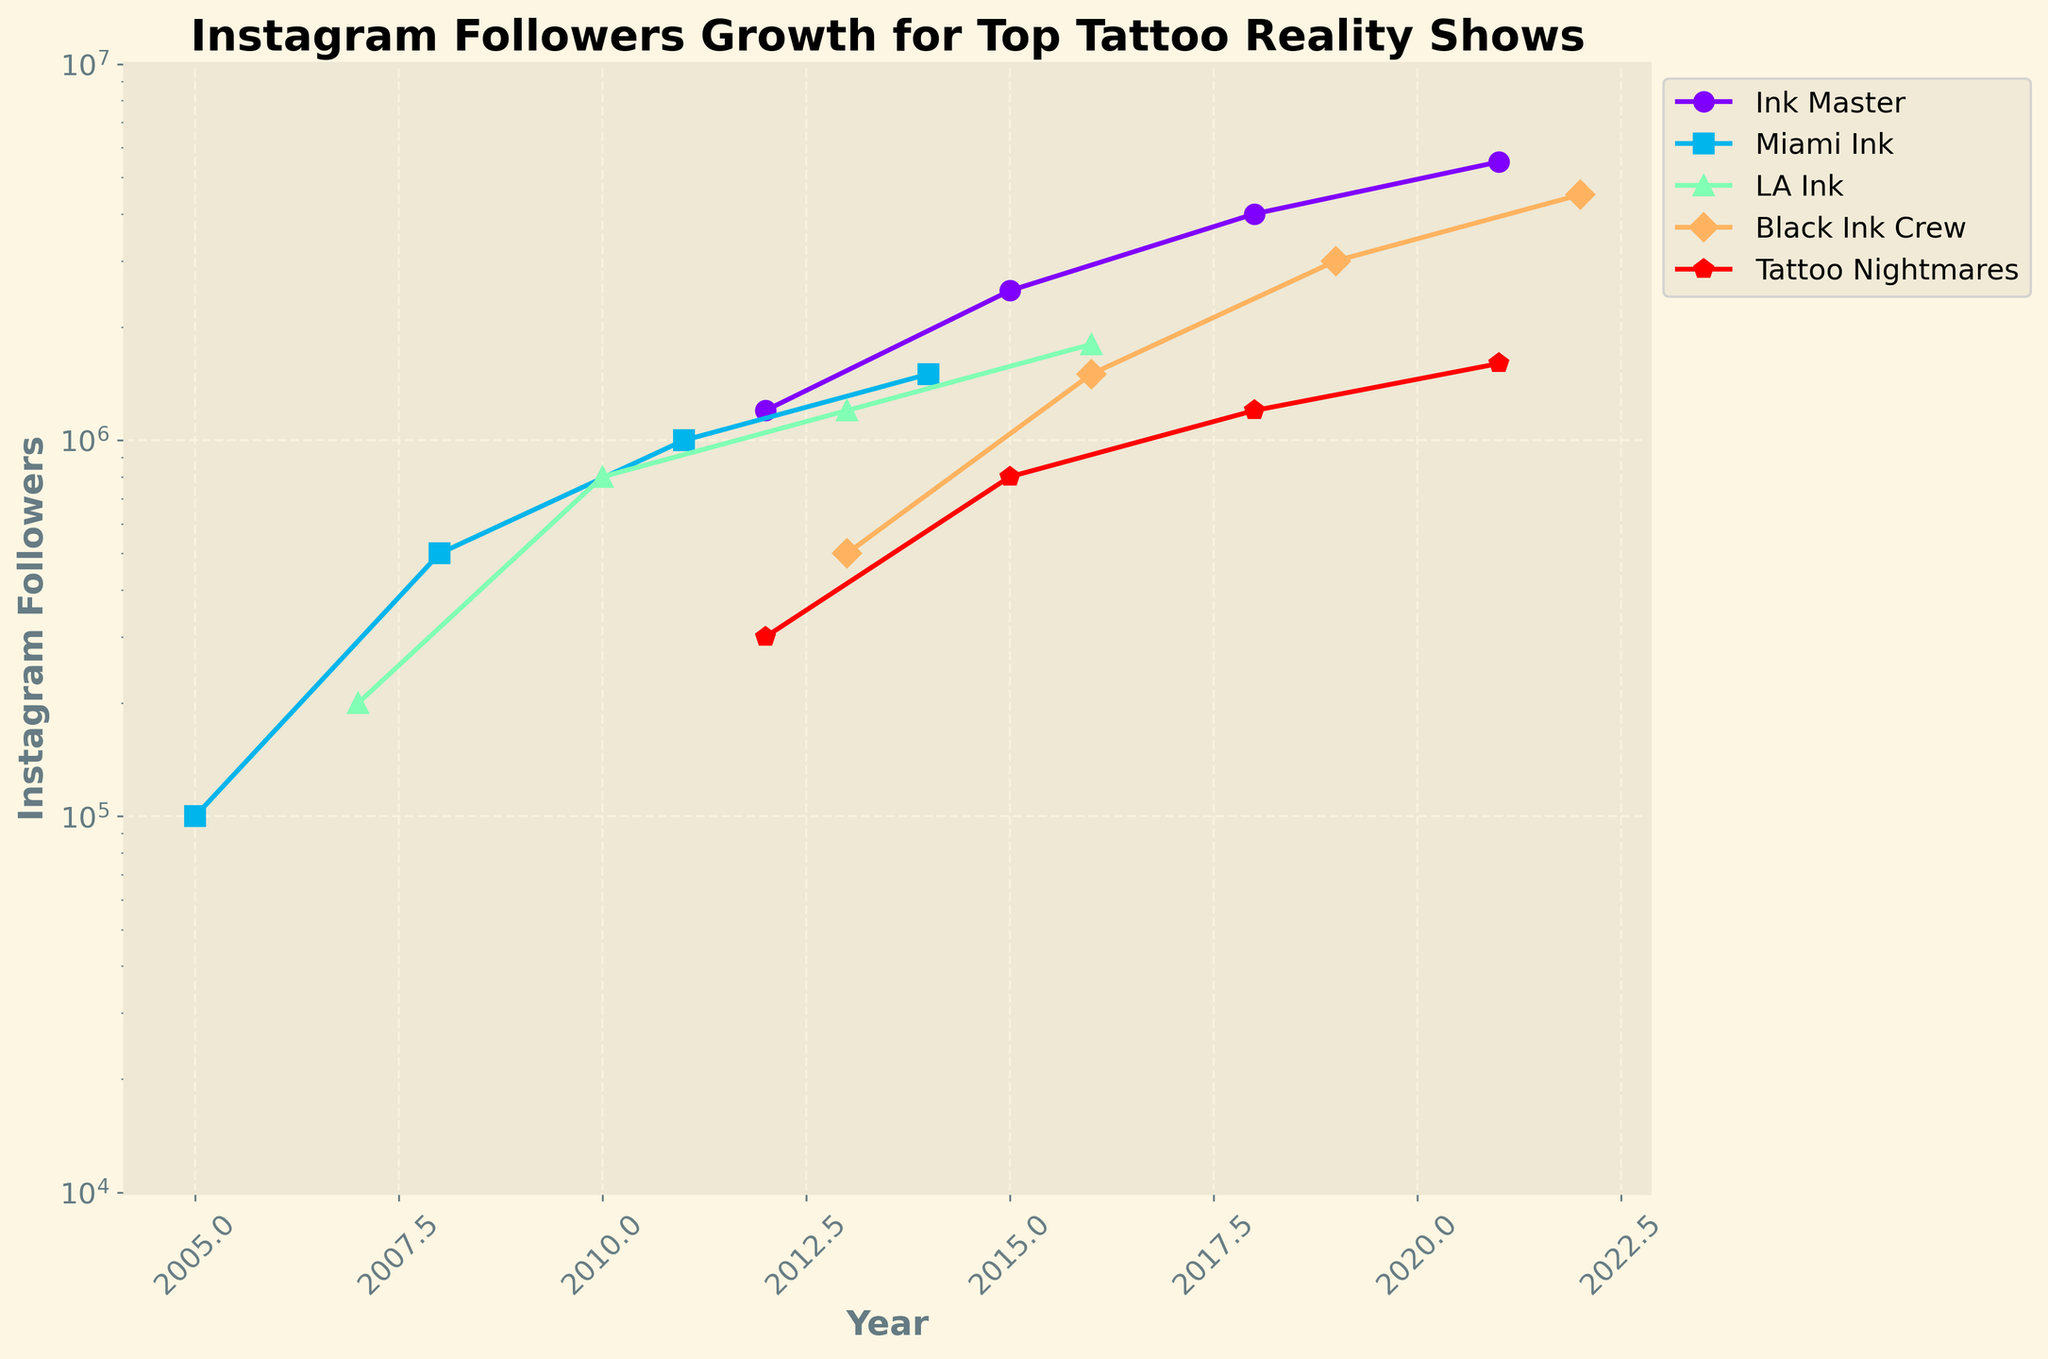How many more Instagram followers does "Ink Master" have in 2021 compared to 2015? Find the number of Instagram followers for "Ink Master" in 2021 (5,500,000) and in 2015 (2,500,000), then subtract the earlier year's value from the later year's value: 5,500,000 - 2,500,000 = 3,000,000
Answer: 3,000,000 Which show had the steepest growth in Instagram followers over the years? Compare the rate of increase in Instagram followers for all shows by looking at the lines' slopes. "Ink Master" shows the steepest rise from 1,200,000 in 2012 to 5,500,000 in 2021.
Answer: Ink Master What is the approximate average number of Instagram followers for "LA Ink" in the data provided? Add the number of Instagram followers for "LA Ink" for each year: 200,000 + 800,000 + 1,200,000 + 1,800,000 = 4,000,000. Then, divide by the number of years (4): 4,000,000 / 4 = 1,000,000
Answer: 1,000,000 Is the number of Instagram followers for "Black Ink Crew" in 2022 greater than for "Miami Ink" in 2014? Compare the number of Instagram followers for "Black Ink Crew" in 2022 (4,500,000) with "Miami Ink" in 2014 (1,500,000). 4,500,000 is greater than 1,500,000.
Answer: Yes Which show had the lowest initial number of Instagram followers upon inclusion in the plot? Identify each show's first data point and compare the Instagram followers. "Miami Ink" in 2005 had 100,000 followers, the lowest initial value among the shows.
Answer: Miami Ink Between 2013 and 2016, which show saw the most significant increase in Instagram followers? Compare the increase in followers in this period for all shows. "Ink Master" gains from 1,200,000 in 2012 to 4,000,000 in 2018, but within 2013-2016 "Black Ink Crew" goes from 500,000 to 1,500,000, which is the largest single-period increase.
Answer: Black Ink Crew How does the growth trend of "Tattoo Nightmares" compare to "Miami Ink"? "Tattoo Nightmares" rises gradually from 300,000 in 2012 to 1,600,000 in 2021. "Miami Ink" shows more fluctuating growth with sharp increases from 100,000 in 2005 to 1,500,000 in 2014. The growth of "Tattoo Nightmares" is steadier.
Answer: steadier In which year did all shows hit at least 1 million Instagram followers? Look for the smallest year in each show's data when their Instagram followers reach at least 1 million. "LA Ink" hits 1 million in 2010, "Black Ink Crew" in 2016, "Tattoo Nightmares" in 2018, "Ink Master" already past this in 2012, "Miami Ink" in 2011. The latest year common to all is 2018.
Answer: 2018 Which shows have lines that change the most gradually on the plot? Compare the plot lines for their smoothness and gradual change. "Tattoo Nightmares" has a more gradual increase from 2012 to 2021 compared to steeper changes seen in other shows like "Ink Master".
Answer: Tattoo Nightmares 